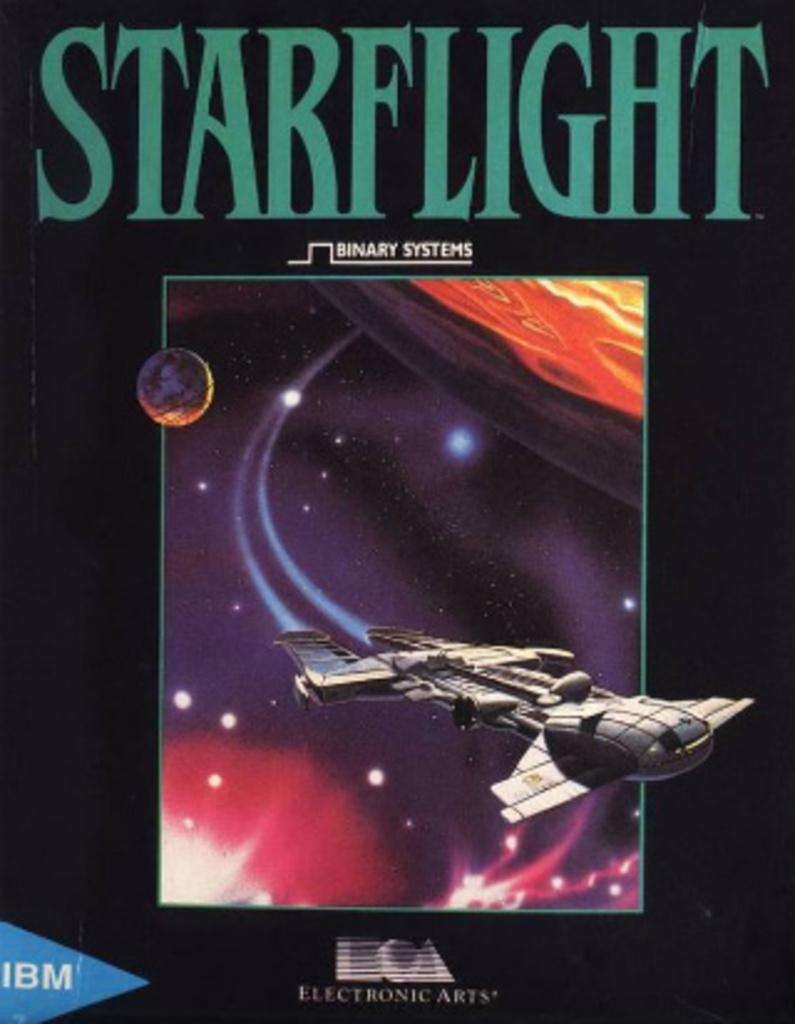Provide a one-sentence caption for the provided image. The cover of the IBM computer game Starflight. 